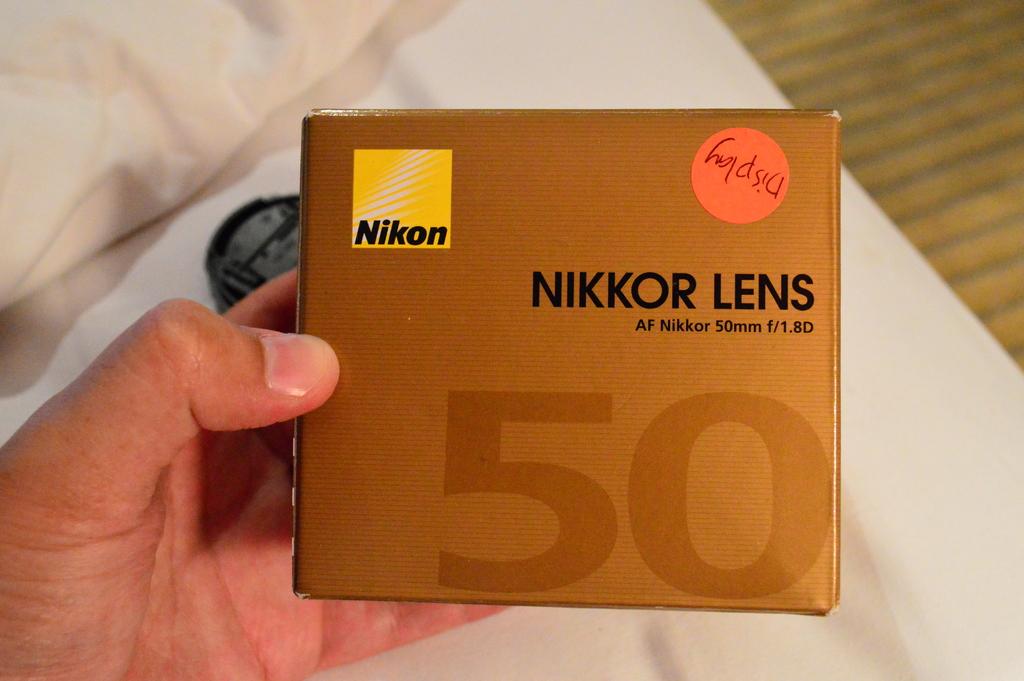What is the name of the camera?
Offer a terse response. Nikon. Is this lens an af lens?
Offer a very short reply. Yes. 